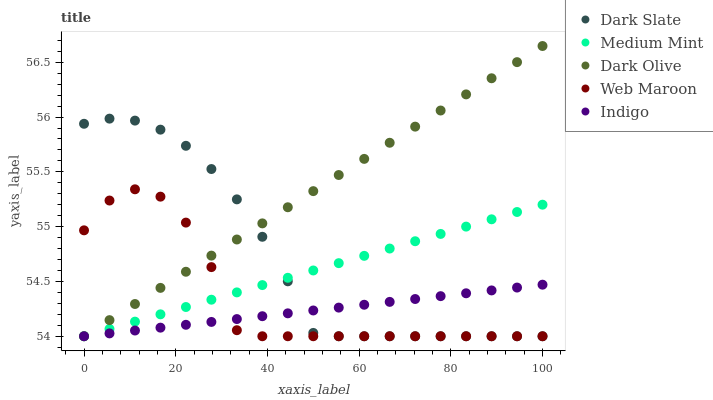Does Indigo have the minimum area under the curve?
Answer yes or no. Yes. Does Dark Olive have the maximum area under the curve?
Answer yes or no. Yes. Does Dark Slate have the minimum area under the curve?
Answer yes or no. No. Does Dark Slate have the maximum area under the curve?
Answer yes or no. No. Is Medium Mint the smoothest?
Answer yes or no. Yes. Is Web Maroon the roughest?
Answer yes or no. Yes. Is Dark Slate the smoothest?
Answer yes or no. No. Is Dark Slate the roughest?
Answer yes or no. No. Does Medium Mint have the lowest value?
Answer yes or no. Yes. Does Dark Olive have the highest value?
Answer yes or no. Yes. Does Dark Slate have the highest value?
Answer yes or no. No. Does Dark Olive intersect Indigo?
Answer yes or no. Yes. Is Dark Olive less than Indigo?
Answer yes or no. No. Is Dark Olive greater than Indigo?
Answer yes or no. No. 